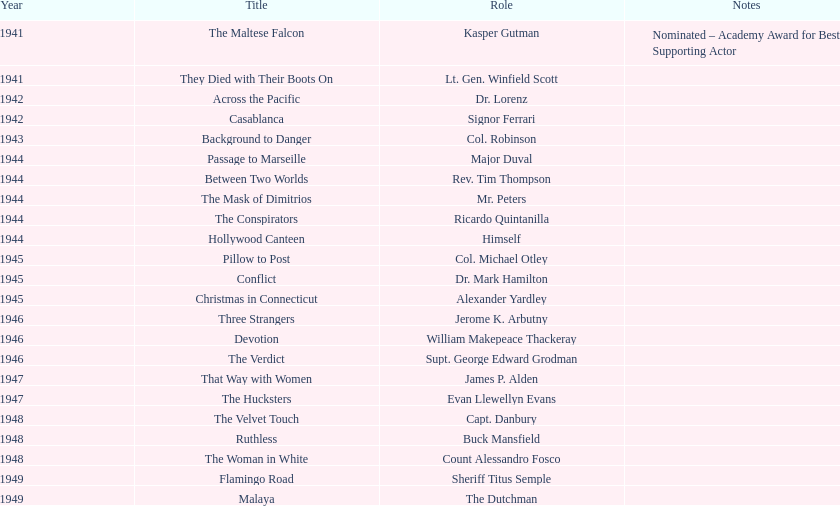How many films has he appeared in from 1941-1949? 23. 